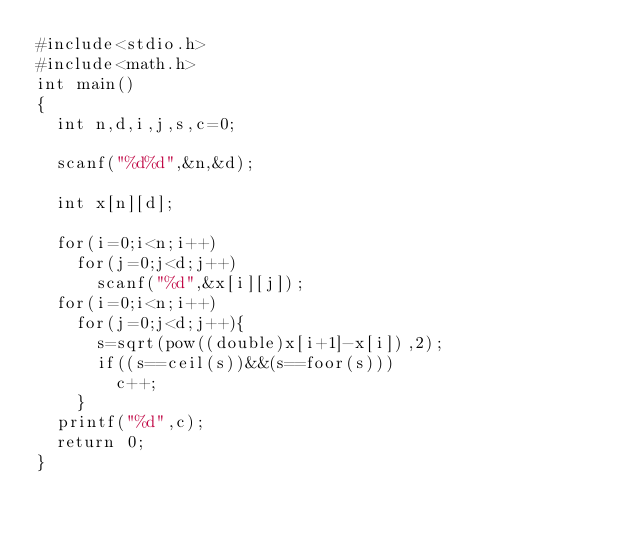Convert code to text. <code><loc_0><loc_0><loc_500><loc_500><_C_>#include<stdio.h>
#include<math.h>
int main()
{
	int n,d,i,j,s,c=0;

	scanf("%d%d",&n,&d);

	int x[n][d];

	for(i=0;i<n;i++)
		for(j=0;j<d;j++)
			scanf("%d",&x[i][j]);
	for(i=0;i<n;i++)
		for(j=0;j<d;j++){
			s=sqrt(pow((double)x[i+1]-x[i]),2);
			if((s==ceil(s))&&(s==foor(s)))
				c++;
		}
	printf("%d",c);
	return 0;
}</code> 